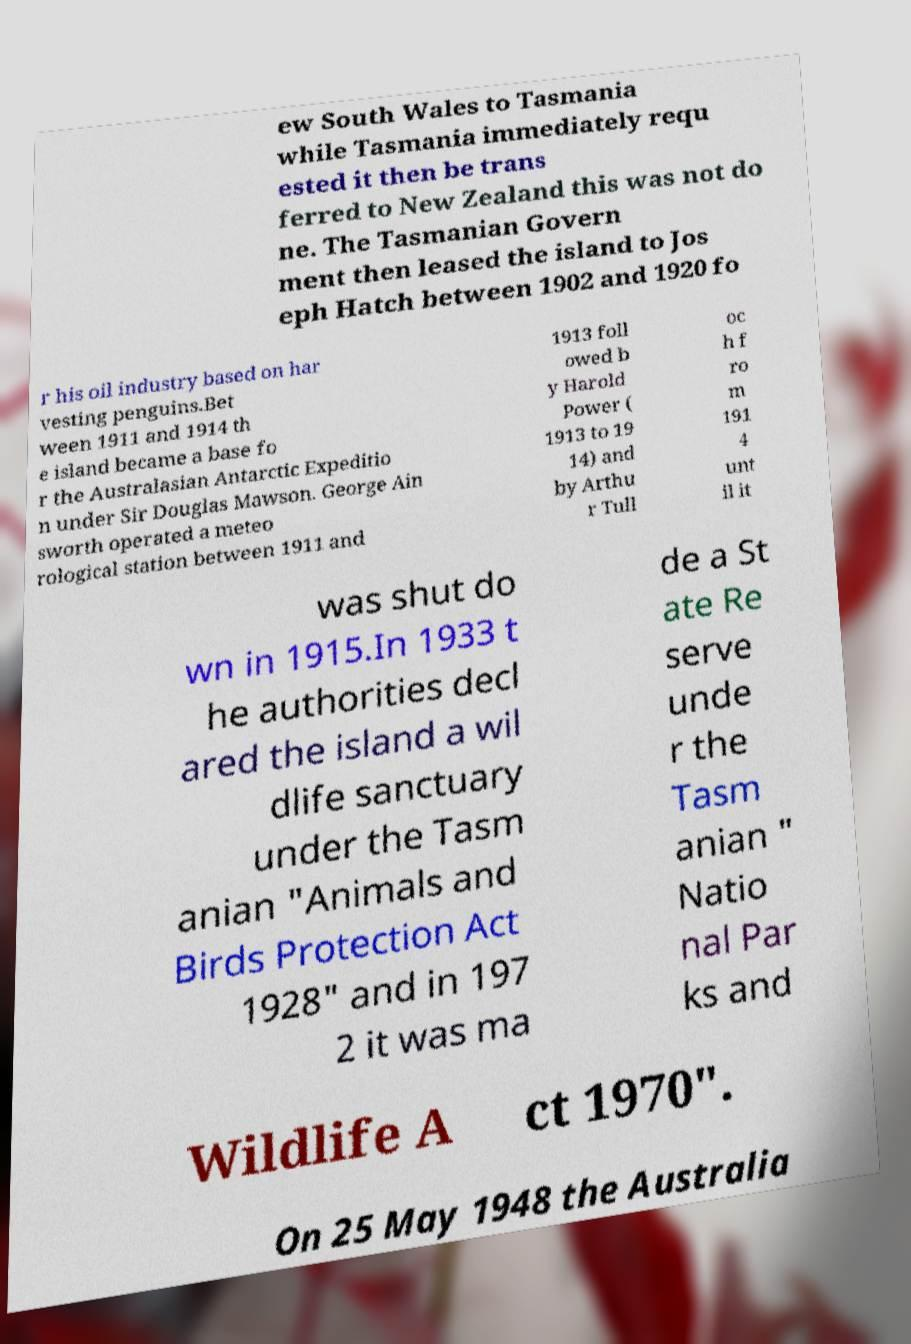Could you assist in decoding the text presented in this image and type it out clearly? ew South Wales to Tasmania while Tasmania immediately requ ested it then be trans ferred to New Zealand this was not do ne. The Tasmanian Govern ment then leased the island to Jos eph Hatch between 1902 and 1920 fo r his oil industry based on har vesting penguins.Bet ween 1911 and 1914 th e island became a base fo r the Australasian Antarctic Expeditio n under Sir Douglas Mawson. George Ain sworth operated a meteo rological station between 1911 and 1913 foll owed b y Harold Power ( 1913 to 19 14) and by Arthu r Tull oc h f ro m 191 4 unt il it was shut do wn in 1915.In 1933 t he authorities decl ared the island a wil dlife sanctuary under the Tasm anian "Animals and Birds Protection Act 1928" and in 197 2 it was ma de a St ate Re serve unde r the Tasm anian " Natio nal Par ks and Wildlife A ct 1970". On 25 May 1948 the Australia 